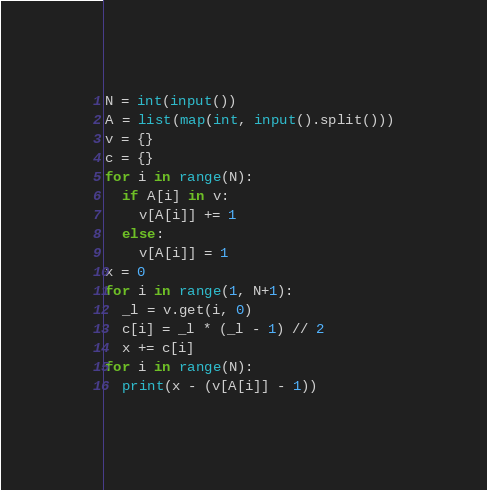Convert code to text. <code><loc_0><loc_0><loc_500><loc_500><_Python_>N = int(input())
A = list(map(int, input().split()))
v = {}
c = {}
for i in range(N):
  if A[i] in v:
    v[A[i]] += 1
  else:
    v[A[i]] = 1
x = 0
for i in range(1, N+1):
  _l = v.get(i, 0)
  c[i] = _l * (_l - 1) // 2
  x += c[i]
for i in range(N):
  print(x - (v[A[i]] - 1))</code> 